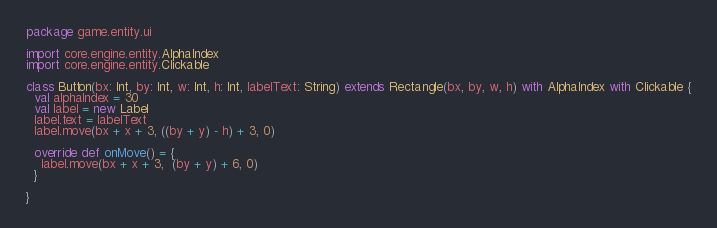<code> <loc_0><loc_0><loc_500><loc_500><_Scala_>package game.entity.ui

import core.engine.entity.AlphaIndex
import core.engine.entity.Clickable

class Button(bx: Int, by: Int, w: Int, h: Int, labelText: String) extends Rectangle(bx, by, w, h) with AlphaIndex with Clickable {
  val alphaIndex = 30
  val label = new Label
  label.text = labelText
  label.move(bx + x + 3, ((by + y) - h) + 3, 0)

  override def onMove() = {
    label.move(bx + x + 3,  (by + y) + 6, 0)
  }

}</code> 